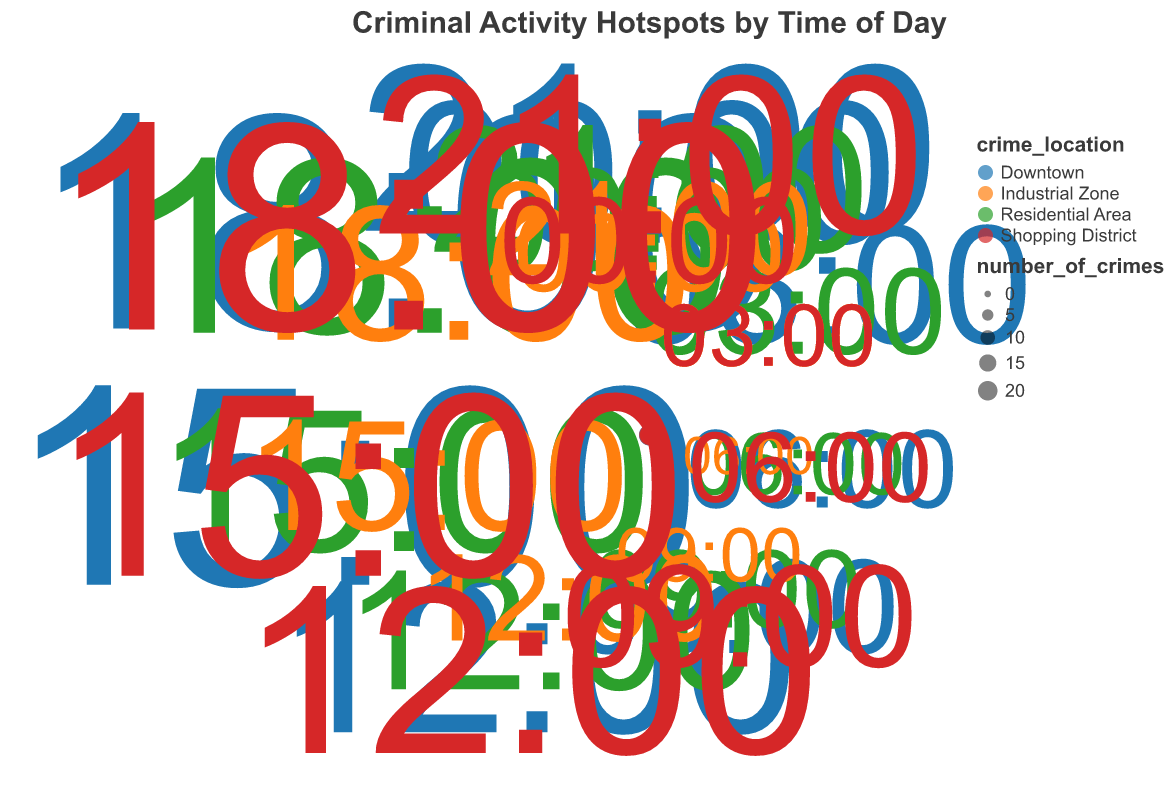What is the title of the figure? The title is usually located at the top of the chart and provides an overview of the visual representation. In this case, it says "Criminal Activity Hotspots by Time of Day".
Answer: Criminal Activity Hotspots by Time of Day What time of day has the highest number of crimes in Downtown? To find this, look at the markers for Downtown (a specific color based on the legend) and identify the one with the largest radius and size. This occurs at 18:00 with 24 crimes.
Answer: 18:00 Which area has the lowest number of crimes at 06:00? Check the data points on the figure that are associated with 06:00 (from the labels), then compare sizes and radii of these points. The Industrial Zone has the smallest number with only 2 crimes.
Answer: Industrial Zone During which time of day do the Residential Area and Shopping District have an equal number of crimes? Look for points associated with Residential Area and Shopping District, then find any overlapping data points in size and radius. Both areas have 5 crimes at 03:00.
Answer: 03:00 What is the difference in the number of crimes between Downtown and Residential Area at 15:00? Identify the data points for Downtown and Residential Area at 15:00. Downtown has 22 crimes while Residential Area has 15. The difference is 22 - 15 = 7.
Answer: 7 How many places have higher criminal activity at 12:00 compared to 00:00? Count data points at 12:00 and 00:00 for all areas. Compare each one: 
- Downtown: 16 (at 12:00) > 15 (at 00:00)
- Residential Area: 12 (at 12:00) > 10 (at 00:00)
- Industrial Zone: 8 (at 12:00) > 7 (at 00:00)
- Shopping District: 18 (at 12:00) > 8 (at 00:00)
All four areas have higher activities.
Answer: 4 Which time of day has the most equal distribution of crimes across all areas? Compare the differences in radii and sizes of the points representing each area for each time of day. 09:00 seems the most balanced as the differences are minimal among Downtown (9), Residential Area (7), Industrial Zone (4), and Shopping District (10).
Answer: 09:00 